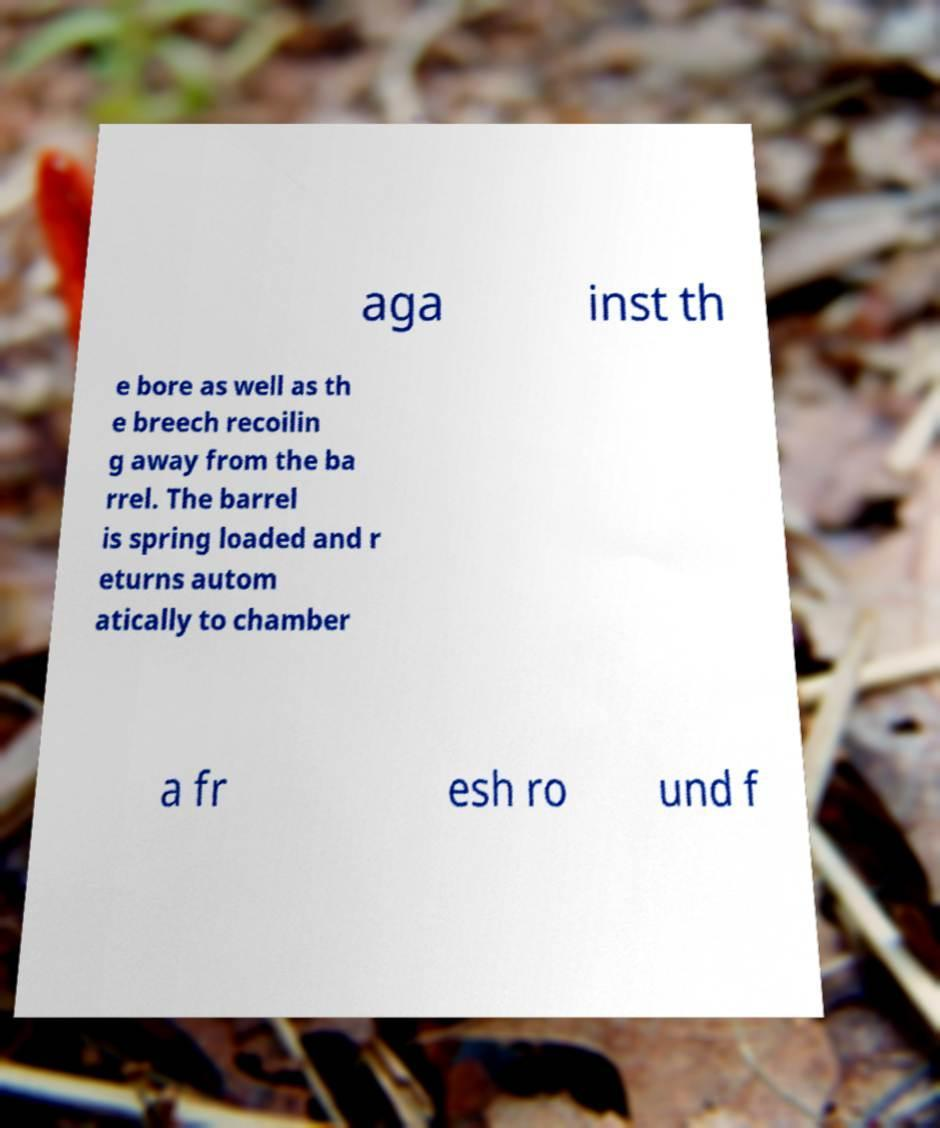Could you assist in decoding the text presented in this image and type it out clearly? aga inst th e bore as well as th e breech recoilin g away from the ba rrel. The barrel is spring loaded and r eturns autom atically to chamber a fr esh ro und f 